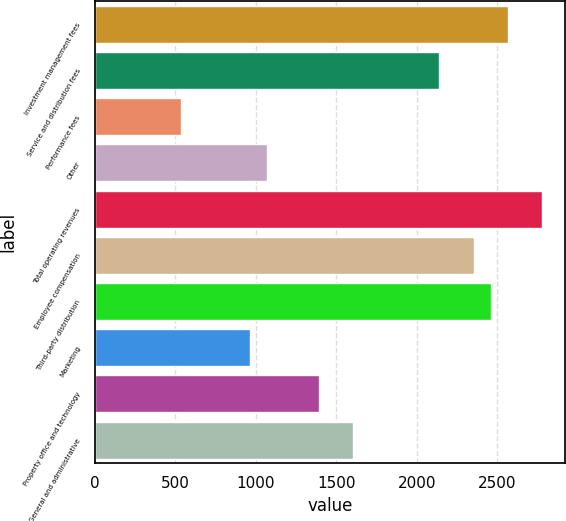Convert chart. <chart><loc_0><loc_0><loc_500><loc_500><bar_chart><fcel>Investment management fees<fcel>Service and distribution fees<fcel>Performance fees<fcel>Other<fcel>Total operating revenues<fcel>Employee compensation<fcel>Third-party distribution<fcel>Marketing<fcel>Property office and technology<fcel>General and administrative<nl><fcel>2567.88<fcel>2139.92<fcel>535.07<fcel>1070.02<fcel>2781.86<fcel>2353.9<fcel>2460.89<fcel>963.03<fcel>1390.99<fcel>1604.97<nl></chart> 